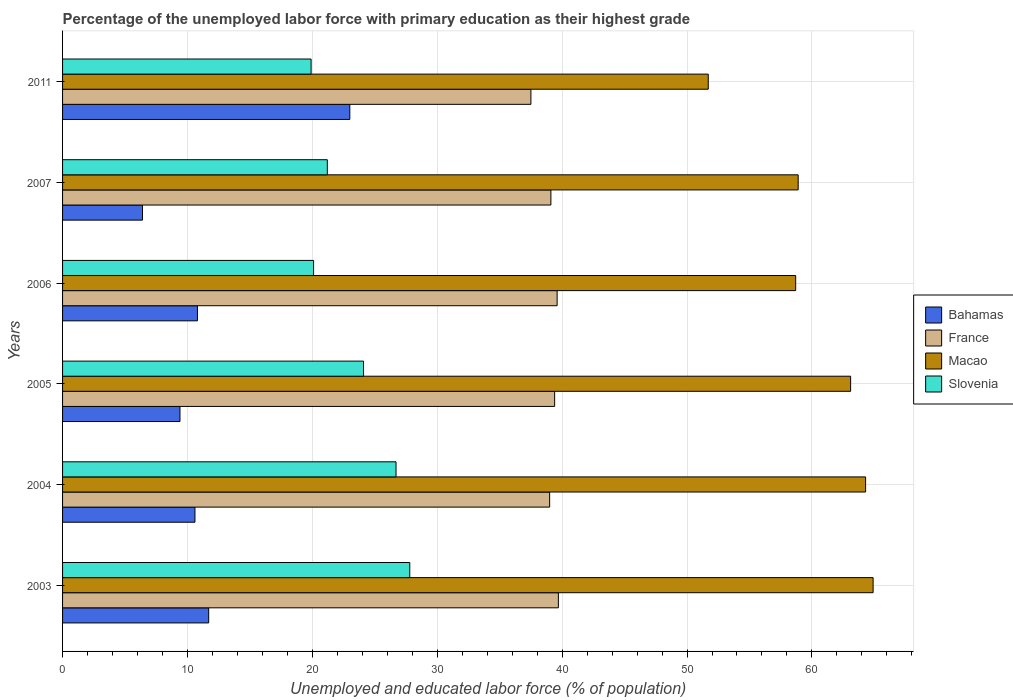How many different coloured bars are there?
Offer a very short reply. 4. What is the label of the 6th group of bars from the top?
Your answer should be compact. 2003. In how many cases, is the number of bars for a given year not equal to the number of legend labels?
Provide a succinct answer. 0. What is the percentage of the unemployed labor force with primary education in Bahamas in 2011?
Give a very brief answer. 23. Across all years, what is the minimum percentage of the unemployed labor force with primary education in Macao?
Your response must be concise. 51.7. What is the total percentage of the unemployed labor force with primary education in Macao in the graph?
Make the answer very short. 361.6. What is the difference between the percentage of the unemployed labor force with primary education in Macao in 2006 and that in 2011?
Keep it short and to the point. 7. What is the difference between the percentage of the unemployed labor force with primary education in France in 2004 and the percentage of the unemployed labor force with primary education in Bahamas in 2006?
Your response must be concise. 28.2. What is the average percentage of the unemployed labor force with primary education in Slovenia per year?
Keep it short and to the point. 23.3. In the year 2005, what is the difference between the percentage of the unemployed labor force with primary education in Macao and percentage of the unemployed labor force with primary education in Bahamas?
Your response must be concise. 53.7. In how many years, is the percentage of the unemployed labor force with primary education in France greater than 6 %?
Offer a terse response. 6. What is the ratio of the percentage of the unemployed labor force with primary education in Slovenia in 2007 to that in 2011?
Your answer should be compact. 1.07. What is the difference between the highest and the second highest percentage of the unemployed labor force with primary education in Slovenia?
Keep it short and to the point. 1.1. What is the difference between the highest and the lowest percentage of the unemployed labor force with primary education in Bahamas?
Provide a succinct answer. 16.6. Is the sum of the percentage of the unemployed labor force with primary education in Macao in 2005 and 2006 greater than the maximum percentage of the unemployed labor force with primary education in Slovenia across all years?
Your response must be concise. Yes. What does the 3rd bar from the top in 2005 represents?
Give a very brief answer. France. What does the 2nd bar from the bottom in 2007 represents?
Provide a succinct answer. France. What is the difference between two consecutive major ticks on the X-axis?
Ensure brevity in your answer.  10. Does the graph contain any zero values?
Provide a succinct answer. No. Does the graph contain grids?
Your response must be concise. Yes. Where does the legend appear in the graph?
Provide a succinct answer. Center right. How are the legend labels stacked?
Ensure brevity in your answer.  Vertical. What is the title of the graph?
Your answer should be very brief. Percentage of the unemployed labor force with primary education as their highest grade. Does "Angola" appear as one of the legend labels in the graph?
Your answer should be very brief. No. What is the label or title of the X-axis?
Your response must be concise. Unemployed and educated labor force (% of population). What is the Unemployed and educated labor force (% of population) of Bahamas in 2003?
Your response must be concise. 11.7. What is the Unemployed and educated labor force (% of population) in France in 2003?
Offer a terse response. 39.7. What is the Unemployed and educated labor force (% of population) of Macao in 2003?
Give a very brief answer. 64.9. What is the Unemployed and educated labor force (% of population) of Slovenia in 2003?
Give a very brief answer. 27.8. What is the Unemployed and educated labor force (% of population) of Bahamas in 2004?
Keep it short and to the point. 10.6. What is the Unemployed and educated labor force (% of population) of France in 2004?
Provide a short and direct response. 39. What is the Unemployed and educated labor force (% of population) in Macao in 2004?
Offer a terse response. 64.3. What is the Unemployed and educated labor force (% of population) in Slovenia in 2004?
Provide a succinct answer. 26.7. What is the Unemployed and educated labor force (% of population) of Bahamas in 2005?
Give a very brief answer. 9.4. What is the Unemployed and educated labor force (% of population) in France in 2005?
Provide a short and direct response. 39.4. What is the Unemployed and educated labor force (% of population) of Macao in 2005?
Offer a terse response. 63.1. What is the Unemployed and educated labor force (% of population) in Slovenia in 2005?
Your answer should be compact. 24.1. What is the Unemployed and educated labor force (% of population) of Bahamas in 2006?
Offer a very short reply. 10.8. What is the Unemployed and educated labor force (% of population) in France in 2006?
Give a very brief answer. 39.6. What is the Unemployed and educated labor force (% of population) in Macao in 2006?
Make the answer very short. 58.7. What is the Unemployed and educated labor force (% of population) in Slovenia in 2006?
Your response must be concise. 20.1. What is the Unemployed and educated labor force (% of population) in Bahamas in 2007?
Ensure brevity in your answer.  6.4. What is the Unemployed and educated labor force (% of population) of France in 2007?
Your response must be concise. 39.1. What is the Unemployed and educated labor force (% of population) in Macao in 2007?
Your answer should be very brief. 58.9. What is the Unemployed and educated labor force (% of population) of Slovenia in 2007?
Your response must be concise. 21.2. What is the Unemployed and educated labor force (% of population) in France in 2011?
Your answer should be compact. 37.5. What is the Unemployed and educated labor force (% of population) of Macao in 2011?
Offer a very short reply. 51.7. What is the Unemployed and educated labor force (% of population) in Slovenia in 2011?
Your answer should be compact. 19.9. Across all years, what is the maximum Unemployed and educated labor force (% of population) of France?
Offer a terse response. 39.7. Across all years, what is the maximum Unemployed and educated labor force (% of population) of Macao?
Your response must be concise. 64.9. Across all years, what is the maximum Unemployed and educated labor force (% of population) in Slovenia?
Your answer should be compact. 27.8. Across all years, what is the minimum Unemployed and educated labor force (% of population) of Bahamas?
Your answer should be very brief. 6.4. Across all years, what is the minimum Unemployed and educated labor force (% of population) in France?
Offer a very short reply. 37.5. Across all years, what is the minimum Unemployed and educated labor force (% of population) in Macao?
Ensure brevity in your answer.  51.7. Across all years, what is the minimum Unemployed and educated labor force (% of population) of Slovenia?
Provide a short and direct response. 19.9. What is the total Unemployed and educated labor force (% of population) in Bahamas in the graph?
Provide a short and direct response. 71.9. What is the total Unemployed and educated labor force (% of population) of France in the graph?
Keep it short and to the point. 234.3. What is the total Unemployed and educated labor force (% of population) in Macao in the graph?
Give a very brief answer. 361.6. What is the total Unemployed and educated labor force (% of population) of Slovenia in the graph?
Give a very brief answer. 139.8. What is the difference between the Unemployed and educated labor force (% of population) in France in 2003 and that in 2004?
Give a very brief answer. 0.7. What is the difference between the Unemployed and educated labor force (% of population) in Macao in 2003 and that in 2004?
Provide a short and direct response. 0.6. What is the difference between the Unemployed and educated labor force (% of population) in Slovenia in 2003 and that in 2004?
Give a very brief answer. 1.1. What is the difference between the Unemployed and educated labor force (% of population) in Bahamas in 2003 and that in 2005?
Keep it short and to the point. 2.3. What is the difference between the Unemployed and educated labor force (% of population) of Slovenia in 2003 and that in 2006?
Your answer should be compact. 7.7. What is the difference between the Unemployed and educated labor force (% of population) of Bahamas in 2003 and that in 2007?
Give a very brief answer. 5.3. What is the difference between the Unemployed and educated labor force (% of population) in Macao in 2003 and that in 2007?
Provide a short and direct response. 6. What is the difference between the Unemployed and educated labor force (% of population) in Macao in 2003 and that in 2011?
Offer a terse response. 13.2. What is the difference between the Unemployed and educated labor force (% of population) in Slovenia in 2003 and that in 2011?
Your answer should be very brief. 7.9. What is the difference between the Unemployed and educated labor force (% of population) in Bahamas in 2004 and that in 2005?
Provide a succinct answer. 1.2. What is the difference between the Unemployed and educated labor force (% of population) of Macao in 2004 and that in 2005?
Make the answer very short. 1.2. What is the difference between the Unemployed and educated labor force (% of population) in Slovenia in 2004 and that in 2005?
Give a very brief answer. 2.6. What is the difference between the Unemployed and educated labor force (% of population) of Slovenia in 2004 and that in 2006?
Your answer should be very brief. 6.6. What is the difference between the Unemployed and educated labor force (% of population) of France in 2004 and that in 2007?
Make the answer very short. -0.1. What is the difference between the Unemployed and educated labor force (% of population) of Macao in 2004 and that in 2007?
Ensure brevity in your answer.  5.4. What is the difference between the Unemployed and educated labor force (% of population) of Slovenia in 2004 and that in 2007?
Keep it short and to the point. 5.5. What is the difference between the Unemployed and educated labor force (% of population) in Macao in 2004 and that in 2011?
Provide a short and direct response. 12.6. What is the difference between the Unemployed and educated labor force (% of population) in Slovenia in 2004 and that in 2011?
Provide a succinct answer. 6.8. What is the difference between the Unemployed and educated labor force (% of population) of France in 2005 and that in 2006?
Offer a very short reply. -0.2. What is the difference between the Unemployed and educated labor force (% of population) of Macao in 2005 and that in 2006?
Offer a terse response. 4.4. What is the difference between the Unemployed and educated labor force (% of population) of France in 2005 and that in 2007?
Offer a very short reply. 0.3. What is the difference between the Unemployed and educated labor force (% of population) in Macao in 2005 and that in 2007?
Keep it short and to the point. 4.2. What is the difference between the Unemployed and educated labor force (% of population) of Slovenia in 2005 and that in 2007?
Your answer should be compact. 2.9. What is the difference between the Unemployed and educated labor force (% of population) of Bahamas in 2005 and that in 2011?
Provide a succinct answer. -13.6. What is the difference between the Unemployed and educated labor force (% of population) of Macao in 2005 and that in 2011?
Your answer should be very brief. 11.4. What is the difference between the Unemployed and educated labor force (% of population) in Slovenia in 2005 and that in 2011?
Ensure brevity in your answer.  4.2. What is the difference between the Unemployed and educated labor force (% of population) in France in 2006 and that in 2007?
Keep it short and to the point. 0.5. What is the difference between the Unemployed and educated labor force (% of population) in Macao in 2006 and that in 2007?
Your response must be concise. -0.2. What is the difference between the Unemployed and educated labor force (% of population) in Slovenia in 2006 and that in 2007?
Provide a succinct answer. -1.1. What is the difference between the Unemployed and educated labor force (% of population) of Bahamas in 2006 and that in 2011?
Provide a succinct answer. -12.2. What is the difference between the Unemployed and educated labor force (% of population) of Slovenia in 2006 and that in 2011?
Make the answer very short. 0.2. What is the difference between the Unemployed and educated labor force (% of population) of Bahamas in 2007 and that in 2011?
Give a very brief answer. -16.6. What is the difference between the Unemployed and educated labor force (% of population) in France in 2007 and that in 2011?
Make the answer very short. 1.6. What is the difference between the Unemployed and educated labor force (% of population) in Bahamas in 2003 and the Unemployed and educated labor force (% of population) in France in 2004?
Offer a terse response. -27.3. What is the difference between the Unemployed and educated labor force (% of population) of Bahamas in 2003 and the Unemployed and educated labor force (% of population) of Macao in 2004?
Keep it short and to the point. -52.6. What is the difference between the Unemployed and educated labor force (% of population) in Bahamas in 2003 and the Unemployed and educated labor force (% of population) in Slovenia in 2004?
Ensure brevity in your answer.  -15. What is the difference between the Unemployed and educated labor force (% of population) of France in 2003 and the Unemployed and educated labor force (% of population) of Macao in 2004?
Your answer should be compact. -24.6. What is the difference between the Unemployed and educated labor force (% of population) in France in 2003 and the Unemployed and educated labor force (% of population) in Slovenia in 2004?
Provide a short and direct response. 13. What is the difference between the Unemployed and educated labor force (% of population) in Macao in 2003 and the Unemployed and educated labor force (% of population) in Slovenia in 2004?
Provide a short and direct response. 38.2. What is the difference between the Unemployed and educated labor force (% of population) in Bahamas in 2003 and the Unemployed and educated labor force (% of population) in France in 2005?
Keep it short and to the point. -27.7. What is the difference between the Unemployed and educated labor force (% of population) of Bahamas in 2003 and the Unemployed and educated labor force (% of population) of Macao in 2005?
Provide a succinct answer. -51.4. What is the difference between the Unemployed and educated labor force (% of population) in Bahamas in 2003 and the Unemployed and educated labor force (% of population) in Slovenia in 2005?
Provide a succinct answer. -12.4. What is the difference between the Unemployed and educated labor force (% of population) in France in 2003 and the Unemployed and educated labor force (% of population) in Macao in 2005?
Give a very brief answer. -23.4. What is the difference between the Unemployed and educated labor force (% of population) in France in 2003 and the Unemployed and educated labor force (% of population) in Slovenia in 2005?
Your answer should be very brief. 15.6. What is the difference between the Unemployed and educated labor force (% of population) of Macao in 2003 and the Unemployed and educated labor force (% of population) of Slovenia in 2005?
Offer a very short reply. 40.8. What is the difference between the Unemployed and educated labor force (% of population) of Bahamas in 2003 and the Unemployed and educated labor force (% of population) of France in 2006?
Offer a terse response. -27.9. What is the difference between the Unemployed and educated labor force (% of population) in Bahamas in 2003 and the Unemployed and educated labor force (% of population) in Macao in 2006?
Provide a succinct answer. -47. What is the difference between the Unemployed and educated labor force (% of population) of Bahamas in 2003 and the Unemployed and educated labor force (% of population) of Slovenia in 2006?
Your answer should be compact. -8.4. What is the difference between the Unemployed and educated labor force (% of population) of France in 2003 and the Unemployed and educated labor force (% of population) of Slovenia in 2006?
Make the answer very short. 19.6. What is the difference between the Unemployed and educated labor force (% of population) in Macao in 2003 and the Unemployed and educated labor force (% of population) in Slovenia in 2006?
Ensure brevity in your answer.  44.8. What is the difference between the Unemployed and educated labor force (% of population) in Bahamas in 2003 and the Unemployed and educated labor force (% of population) in France in 2007?
Offer a very short reply. -27.4. What is the difference between the Unemployed and educated labor force (% of population) of Bahamas in 2003 and the Unemployed and educated labor force (% of population) of Macao in 2007?
Ensure brevity in your answer.  -47.2. What is the difference between the Unemployed and educated labor force (% of population) of France in 2003 and the Unemployed and educated labor force (% of population) of Macao in 2007?
Your answer should be compact. -19.2. What is the difference between the Unemployed and educated labor force (% of population) of France in 2003 and the Unemployed and educated labor force (% of population) of Slovenia in 2007?
Ensure brevity in your answer.  18.5. What is the difference between the Unemployed and educated labor force (% of population) of Macao in 2003 and the Unemployed and educated labor force (% of population) of Slovenia in 2007?
Keep it short and to the point. 43.7. What is the difference between the Unemployed and educated labor force (% of population) in Bahamas in 2003 and the Unemployed and educated labor force (% of population) in France in 2011?
Provide a short and direct response. -25.8. What is the difference between the Unemployed and educated labor force (% of population) in Bahamas in 2003 and the Unemployed and educated labor force (% of population) in Macao in 2011?
Keep it short and to the point. -40. What is the difference between the Unemployed and educated labor force (% of population) in France in 2003 and the Unemployed and educated labor force (% of population) in Slovenia in 2011?
Your answer should be compact. 19.8. What is the difference between the Unemployed and educated labor force (% of population) in Macao in 2003 and the Unemployed and educated labor force (% of population) in Slovenia in 2011?
Provide a short and direct response. 45. What is the difference between the Unemployed and educated labor force (% of population) of Bahamas in 2004 and the Unemployed and educated labor force (% of population) of France in 2005?
Provide a succinct answer. -28.8. What is the difference between the Unemployed and educated labor force (% of population) of Bahamas in 2004 and the Unemployed and educated labor force (% of population) of Macao in 2005?
Your response must be concise. -52.5. What is the difference between the Unemployed and educated labor force (% of population) in Bahamas in 2004 and the Unemployed and educated labor force (% of population) in Slovenia in 2005?
Offer a very short reply. -13.5. What is the difference between the Unemployed and educated labor force (% of population) in France in 2004 and the Unemployed and educated labor force (% of population) in Macao in 2005?
Provide a short and direct response. -24.1. What is the difference between the Unemployed and educated labor force (% of population) of France in 2004 and the Unemployed and educated labor force (% of population) of Slovenia in 2005?
Your response must be concise. 14.9. What is the difference between the Unemployed and educated labor force (% of population) of Macao in 2004 and the Unemployed and educated labor force (% of population) of Slovenia in 2005?
Give a very brief answer. 40.2. What is the difference between the Unemployed and educated labor force (% of population) in Bahamas in 2004 and the Unemployed and educated labor force (% of population) in France in 2006?
Provide a short and direct response. -29. What is the difference between the Unemployed and educated labor force (% of population) of Bahamas in 2004 and the Unemployed and educated labor force (% of population) of Macao in 2006?
Offer a very short reply. -48.1. What is the difference between the Unemployed and educated labor force (% of population) of France in 2004 and the Unemployed and educated labor force (% of population) of Macao in 2006?
Provide a succinct answer. -19.7. What is the difference between the Unemployed and educated labor force (% of population) of Macao in 2004 and the Unemployed and educated labor force (% of population) of Slovenia in 2006?
Offer a terse response. 44.2. What is the difference between the Unemployed and educated labor force (% of population) of Bahamas in 2004 and the Unemployed and educated labor force (% of population) of France in 2007?
Provide a succinct answer. -28.5. What is the difference between the Unemployed and educated labor force (% of population) in Bahamas in 2004 and the Unemployed and educated labor force (% of population) in Macao in 2007?
Provide a succinct answer. -48.3. What is the difference between the Unemployed and educated labor force (% of population) of France in 2004 and the Unemployed and educated labor force (% of population) of Macao in 2007?
Give a very brief answer. -19.9. What is the difference between the Unemployed and educated labor force (% of population) in Macao in 2004 and the Unemployed and educated labor force (% of population) in Slovenia in 2007?
Give a very brief answer. 43.1. What is the difference between the Unemployed and educated labor force (% of population) in Bahamas in 2004 and the Unemployed and educated labor force (% of population) in France in 2011?
Your answer should be very brief. -26.9. What is the difference between the Unemployed and educated labor force (% of population) of Bahamas in 2004 and the Unemployed and educated labor force (% of population) of Macao in 2011?
Make the answer very short. -41.1. What is the difference between the Unemployed and educated labor force (% of population) in Bahamas in 2004 and the Unemployed and educated labor force (% of population) in Slovenia in 2011?
Offer a terse response. -9.3. What is the difference between the Unemployed and educated labor force (% of population) in France in 2004 and the Unemployed and educated labor force (% of population) in Slovenia in 2011?
Your answer should be compact. 19.1. What is the difference between the Unemployed and educated labor force (% of population) in Macao in 2004 and the Unemployed and educated labor force (% of population) in Slovenia in 2011?
Provide a succinct answer. 44.4. What is the difference between the Unemployed and educated labor force (% of population) of Bahamas in 2005 and the Unemployed and educated labor force (% of population) of France in 2006?
Offer a very short reply. -30.2. What is the difference between the Unemployed and educated labor force (% of population) in Bahamas in 2005 and the Unemployed and educated labor force (% of population) in Macao in 2006?
Provide a short and direct response. -49.3. What is the difference between the Unemployed and educated labor force (% of population) of France in 2005 and the Unemployed and educated labor force (% of population) of Macao in 2006?
Provide a succinct answer. -19.3. What is the difference between the Unemployed and educated labor force (% of population) in France in 2005 and the Unemployed and educated labor force (% of population) in Slovenia in 2006?
Make the answer very short. 19.3. What is the difference between the Unemployed and educated labor force (% of population) of Bahamas in 2005 and the Unemployed and educated labor force (% of population) of France in 2007?
Offer a very short reply. -29.7. What is the difference between the Unemployed and educated labor force (% of population) of Bahamas in 2005 and the Unemployed and educated labor force (% of population) of Macao in 2007?
Provide a short and direct response. -49.5. What is the difference between the Unemployed and educated labor force (% of population) in France in 2005 and the Unemployed and educated labor force (% of population) in Macao in 2007?
Offer a terse response. -19.5. What is the difference between the Unemployed and educated labor force (% of population) of Macao in 2005 and the Unemployed and educated labor force (% of population) of Slovenia in 2007?
Your response must be concise. 41.9. What is the difference between the Unemployed and educated labor force (% of population) of Bahamas in 2005 and the Unemployed and educated labor force (% of population) of France in 2011?
Your response must be concise. -28.1. What is the difference between the Unemployed and educated labor force (% of population) of Bahamas in 2005 and the Unemployed and educated labor force (% of population) of Macao in 2011?
Offer a terse response. -42.3. What is the difference between the Unemployed and educated labor force (% of population) of Bahamas in 2005 and the Unemployed and educated labor force (% of population) of Slovenia in 2011?
Provide a short and direct response. -10.5. What is the difference between the Unemployed and educated labor force (% of population) in France in 2005 and the Unemployed and educated labor force (% of population) in Macao in 2011?
Offer a very short reply. -12.3. What is the difference between the Unemployed and educated labor force (% of population) in Macao in 2005 and the Unemployed and educated labor force (% of population) in Slovenia in 2011?
Your response must be concise. 43.2. What is the difference between the Unemployed and educated labor force (% of population) in Bahamas in 2006 and the Unemployed and educated labor force (% of population) in France in 2007?
Your response must be concise. -28.3. What is the difference between the Unemployed and educated labor force (% of population) of Bahamas in 2006 and the Unemployed and educated labor force (% of population) of Macao in 2007?
Provide a short and direct response. -48.1. What is the difference between the Unemployed and educated labor force (% of population) of Bahamas in 2006 and the Unemployed and educated labor force (% of population) of Slovenia in 2007?
Ensure brevity in your answer.  -10.4. What is the difference between the Unemployed and educated labor force (% of population) of France in 2006 and the Unemployed and educated labor force (% of population) of Macao in 2007?
Ensure brevity in your answer.  -19.3. What is the difference between the Unemployed and educated labor force (% of population) of France in 2006 and the Unemployed and educated labor force (% of population) of Slovenia in 2007?
Offer a terse response. 18.4. What is the difference between the Unemployed and educated labor force (% of population) of Macao in 2006 and the Unemployed and educated labor force (% of population) of Slovenia in 2007?
Ensure brevity in your answer.  37.5. What is the difference between the Unemployed and educated labor force (% of population) in Bahamas in 2006 and the Unemployed and educated labor force (% of population) in France in 2011?
Your answer should be very brief. -26.7. What is the difference between the Unemployed and educated labor force (% of population) in Bahamas in 2006 and the Unemployed and educated labor force (% of population) in Macao in 2011?
Keep it short and to the point. -40.9. What is the difference between the Unemployed and educated labor force (% of population) of Bahamas in 2006 and the Unemployed and educated labor force (% of population) of Slovenia in 2011?
Your answer should be very brief. -9.1. What is the difference between the Unemployed and educated labor force (% of population) of France in 2006 and the Unemployed and educated labor force (% of population) of Slovenia in 2011?
Keep it short and to the point. 19.7. What is the difference between the Unemployed and educated labor force (% of population) of Macao in 2006 and the Unemployed and educated labor force (% of population) of Slovenia in 2011?
Ensure brevity in your answer.  38.8. What is the difference between the Unemployed and educated labor force (% of population) in Bahamas in 2007 and the Unemployed and educated labor force (% of population) in France in 2011?
Your answer should be compact. -31.1. What is the difference between the Unemployed and educated labor force (% of population) of Bahamas in 2007 and the Unemployed and educated labor force (% of population) of Macao in 2011?
Offer a terse response. -45.3. What is the difference between the Unemployed and educated labor force (% of population) of Bahamas in 2007 and the Unemployed and educated labor force (% of population) of Slovenia in 2011?
Offer a terse response. -13.5. What is the difference between the Unemployed and educated labor force (% of population) in Macao in 2007 and the Unemployed and educated labor force (% of population) in Slovenia in 2011?
Provide a succinct answer. 39. What is the average Unemployed and educated labor force (% of population) of Bahamas per year?
Offer a terse response. 11.98. What is the average Unemployed and educated labor force (% of population) of France per year?
Provide a succinct answer. 39.05. What is the average Unemployed and educated labor force (% of population) in Macao per year?
Ensure brevity in your answer.  60.27. What is the average Unemployed and educated labor force (% of population) of Slovenia per year?
Your answer should be compact. 23.3. In the year 2003, what is the difference between the Unemployed and educated labor force (% of population) in Bahamas and Unemployed and educated labor force (% of population) in France?
Ensure brevity in your answer.  -28. In the year 2003, what is the difference between the Unemployed and educated labor force (% of population) of Bahamas and Unemployed and educated labor force (% of population) of Macao?
Your response must be concise. -53.2. In the year 2003, what is the difference between the Unemployed and educated labor force (% of population) in Bahamas and Unemployed and educated labor force (% of population) in Slovenia?
Make the answer very short. -16.1. In the year 2003, what is the difference between the Unemployed and educated labor force (% of population) of France and Unemployed and educated labor force (% of population) of Macao?
Give a very brief answer. -25.2. In the year 2003, what is the difference between the Unemployed and educated labor force (% of population) in France and Unemployed and educated labor force (% of population) in Slovenia?
Ensure brevity in your answer.  11.9. In the year 2003, what is the difference between the Unemployed and educated labor force (% of population) in Macao and Unemployed and educated labor force (% of population) in Slovenia?
Your answer should be compact. 37.1. In the year 2004, what is the difference between the Unemployed and educated labor force (% of population) in Bahamas and Unemployed and educated labor force (% of population) in France?
Make the answer very short. -28.4. In the year 2004, what is the difference between the Unemployed and educated labor force (% of population) in Bahamas and Unemployed and educated labor force (% of population) in Macao?
Your response must be concise. -53.7. In the year 2004, what is the difference between the Unemployed and educated labor force (% of population) in Bahamas and Unemployed and educated labor force (% of population) in Slovenia?
Offer a terse response. -16.1. In the year 2004, what is the difference between the Unemployed and educated labor force (% of population) in France and Unemployed and educated labor force (% of population) in Macao?
Ensure brevity in your answer.  -25.3. In the year 2004, what is the difference between the Unemployed and educated labor force (% of population) in France and Unemployed and educated labor force (% of population) in Slovenia?
Offer a terse response. 12.3. In the year 2004, what is the difference between the Unemployed and educated labor force (% of population) of Macao and Unemployed and educated labor force (% of population) of Slovenia?
Your answer should be very brief. 37.6. In the year 2005, what is the difference between the Unemployed and educated labor force (% of population) of Bahamas and Unemployed and educated labor force (% of population) of France?
Offer a very short reply. -30. In the year 2005, what is the difference between the Unemployed and educated labor force (% of population) of Bahamas and Unemployed and educated labor force (% of population) of Macao?
Offer a very short reply. -53.7. In the year 2005, what is the difference between the Unemployed and educated labor force (% of population) of Bahamas and Unemployed and educated labor force (% of population) of Slovenia?
Provide a succinct answer. -14.7. In the year 2005, what is the difference between the Unemployed and educated labor force (% of population) of France and Unemployed and educated labor force (% of population) of Macao?
Keep it short and to the point. -23.7. In the year 2005, what is the difference between the Unemployed and educated labor force (% of population) of France and Unemployed and educated labor force (% of population) of Slovenia?
Give a very brief answer. 15.3. In the year 2006, what is the difference between the Unemployed and educated labor force (% of population) in Bahamas and Unemployed and educated labor force (% of population) in France?
Provide a short and direct response. -28.8. In the year 2006, what is the difference between the Unemployed and educated labor force (% of population) in Bahamas and Unemployed and educated labor force (% of population) in Macao?
Offer a very short reply. -47.9. In the year 2006, what is the difference between the Unemployed and educated labor force (% of population) of France and Unemployed and educated labor force (% of population) of Macao?
Offer a terse response. -19.1. In the year 2006, what is the difference between the Unemployed and educated labor force (% of population) of France and Unemployed and educated labor force (% of population) of Slovenia?
Your answer should be very brief. 19.5. In the year 2006, what is the difference between the Unemployed and educated labor force (% of population) in Macao and Unemployed and educated labor force (% of population) in Slovenia?
Provide a short and direct response. 38.6. In the year 2007, what is the difference between the Unemployed and educated labor force (% of population) in Bahamas and Unemployed and educated labor force (% of population) in France?
Offer a terse response. -32.7. In the year 2007, what is the difference between the Unemployed and educated labor force (% of population) of Bahamas and Unemployed and educated labor force (% of population) of Macao?
Offer a very short reply. -52.5. In the year 2007, what is the difference between the Unemployed and educated labor force (% of population) of Bahamas and Unemployed and educated labor force (% of population) of Slovenia?
Provide a short and direct response. -14.8. In the year 2007, what is the difference between the Unemployed and educated labor force (% of population) of France and Unemployed and educated labor force (% of population) of Macao?
Your answer should be compact. -19.8. In the year 2007, what is the difference between the Unemployed and educated labor force (% of population) in France and Unemployed and educated labor force (% of population) in Slovenia?
Provide a succinct answer. 17.9. In the year 2007, what is the difference between the Unemployed and educated labor force (% of population) of Macao and Unemployed and educated labor force (% of population) of Slovenia?
Your answer should be compact. 37.7. In the year 2011, what is the difference between the Unemployed and educated labor force (% of population) of Bahamas and Unemployed and educated labor force (% of population) of France?
Make the answer very short. -14.5. In the year 2011, what is the difference between the Unemployed and educated labor force (% of population) of Bahamas and Unemployed and educated labor force (% of population) of Macao?
Offer a terse response. -28.7. In the year 2011, what is the difference between the Unemployed and educated labor force (% of population) in Macao and Unemployed and educated labor force (% of population) in Slovenia?
Provide a short and direct response. 31.8. What is the ratio of the Unemployed and educated labor force (% of population) of Bahamas in 2003 to that in 2004?
Provide a short and direct response. 1.1. What is the ratio of the Unemployed and educated labor force (% of population) of France in 2003 to that in 2004?
Provide a succinct answer. 1.02. What is the ratio of the Unemployed and educated labor force (% of population) in Macao in 2003 to that in 2004?
Provide a succinct answer. 1.01. What is the ratio of the Unemployed and educated labor force (% of population) in Slovenia in 2003 to that in 2004?
Give a very brief answer. 1.04. What is the ratio of the Unemployed and educated labor force (% of population) of Bahamas in 2003 to that in 2005?
Make the answer very short. 1.24. What is the ratio of the Unemployed and educated labor force (% of population) in France in 2003 to that in 2005?
Offer a very short reply. 1.01. What is the ratio of the Unemployed and educated labor force (% of population) of Macao in 2003 to that in 2005?
Offer a terse response. 1.03. What is the ratio of the Unemployed and educated labor force (% of population) of Slovenia in 2003 to that in 2005?
Offer a very short reply. 1.15. What is the ratio of the Unemployed and educated labor force (% of population) of Bahamas in 2003 to that in 2006?
Your response must be concise. 1.08. What is the ratio of the Unemployed and educated labor force (% of population) in Macao in 2003 to that in 2006?
Provide a short and direct response. 1.11. What is the ratio of the Unemployed and educated labor force (% of population) in Slovenia in 2003 to that in 2006?
Give a very brief answer. 1.38. What is the ratio of the Unemployed and educated labor force (% of population) in Bahamas in 2003 to that in 2007?
Your answer should be compact. 1.83. What is the ratio of the Unemployed and educated labor force (% of population) of France in 2003 to that in 2007?
Your answer should be compact. 1.02. What is the ratio of the Unemployed and educated labor force (% of population) of Macao in 2003 to that in 2007?
Provide a succinct answer. 1.1. What is the ratio of the Unemployed and educated labor force (% of population) in Slovenia in 2003 to that in 2007?
Provide a short and direct response. 1.31. What is the ratio of the Unemployed and educated labor force (% of population) of Bahamas in 2003 to that in 2011?
Offer a terse response. 0.51. What is the ratio of the Unemployed and educated labor force (% of population) in France in 2003 to that in 2011?
Offer a terse response. 1.06. What is the ratio of the Unemployed and educated labor force (% of population) of Macao in 2003 to that in 2011?
Provide a succinct answer. 1.26. What is the ratio of the Unemployed and educated labor force (% of population) in Slovenia in 2003 to that in 2011?
Your response must be concise. 1.4. What is the ratio of the Unemployed and educated labor force (% of population) of Bahamas in 2004 to that in 2005?
Your answer should be very brief. 1.13. What is the ratio of the Unemployed and educated labor force (% of population) of Macao in 2004 to that in 2005?
Offer a terse response. 1.02. What is the ratio of the Unemployed and educated labor force (% of population) of Slovenia in 2004 to that in 2005?
Your response must be concise. 1.11. What is the ratio of the Unemployed and educated labor force (% of population) of Bahamas in 2004 to that in 2006?
Give a very brief answer. 0.98. What is the ratio of the Unemployed and educated labor force (% of population) in Macao in 2004 to that in 2006?
Ensure brevity in your answer.  1.1. What is the ratio of the Unemployed and educated labor force (% of population) of Slovenia in 2004 to that in 2006?
Provide a short and direct response. 1.33. What is the ratio of the Unemployed and educated labor force (% of population) of Bahamas in 2004 to that in 2007?
Make the answer very short. 1.66. What is the ratio of the Unemployed and educated labor force (% of population) of France in 2004 to that in 2007?
Ensure brevity in your answer.  1. What is the ratio of the Unemployed and educated labor force (% of population) in Macao in 2004 to that in 2007?
Your response must be concise. 1.09. What is the ratio of the Unemployed and educated labor force (% of population) of Slovenia in 2004 to that in 2007?
Provide a succinct answer. 1.26. What is the ratio of the Unemployed and educated labor force (% of population) in Bahamas in 2004 to that in 2011?
Keep it short and to the point. 0.46. What is the ratio of the Unemployed and educated labor force (% of population) in France in 2004 to that in 2011?
Provide a short and direct response. 1.04. What is the ratio of the Unemployed and educated labor force (% of population) in Macao in 2004 to that in 2011?
Offer a very short reply. 1.24. What is the ratio of the Unemployed and educated labor force (% of population) of Slovenia in 2004 to that in 2011?
Offer a terse response. 1.34. What is the ratio of the Unemployed and educated labor force (% of population) in Bahamas in 2005 to that in 2006?
Your response must be concise. 0.87. What is the ratio of the Unemployed and educated labor force (% of population) of Macao in 2005 to that in 2006?
Your answer should be very brief. 1.07. What is the ratio of the Unemployed and educated labor force (% of population) of Slovenia in 2005 to that in 2006?
Your answer should be compact. 1.2. What is the ratio of the Unemployed and educated labor force (% of population) of Bahamas in 2005 to that in 2007?
Your response must be concise. 1.47. What is the ratio of the Unemployed and educated labor force (% of population) of France in 2005 to that in 2007?
Ensure brevity in your answer.  1.01. What is the ratio of the Unemployed and educated labor force (% of population) of Macao in 2005 to that in 2007?
Provide a short and direct response. 1.07. What is the ratio of the Unemployed and educated labor force (% of population) of Slovenia in 2005 to that in 2007?
Ensure brevity in your answer.  1.14. What is the ratio of the Unemployed and educated labor force (% of population) in Bahamas in 2005 to that in 2011?
Offer a terse response. 0.41. What is the ratio of the Unemployed and educated labor force (% of population) in France in 2005 to that in 2011?
Your answer should be compact. 1.05. What is the ratio of the Unemployed and educated labor force (% of population) in Macao in 2005 to that in 2011?
Give a very brief answer. 1.22. What is the ratio of the Unemployed and educated labor force (% of population) in Slovenia in 2005 to that in 2011?
Your answer should be very brief. 1.21. What is the ratio of the Unemployed and educated labor force (% of population) of Bahamas in 2006 to that in 2007?
Your answer should be compact. 1.69. What is the ratio of the Unemployed and educated labor force (% of population) of France in 2006 to that in 2007?
Your answer should be very brief. 1.01. What is the ratio of the Unemployed and educated labor force (% of population) in Macao in 2006 to that in 2007?
Offer a very short reply. 1. What is the ratio of the Unemployed and educated labor force (% of population) in Slovenia in 2006 to that in 2007?
Provide a short and direct response. 0.95. What is the ratio of the Unemployed and educated labor force (% of population) in Bahamas in 2006 to that in 2011?
Provide a short and direct response. 0.47. What is the ratio of the Unemployed and educated labor force (% of population) in France in 2006 to that in 2011?
Provide a succinct answer. 1.06. What is the ratio of the Unemployed and educated labor force (% of population) in Macao in 2006 to that in 2011?
Give a very brief answer. 1.14. What is the ratio of the Unemployed and educated labor force (% of population) in Slovenia in 2006 to that in 2011?
Provide a succinct answer. 1.01. What is the ratio of the Unemployed and educated labor force (% of population) of Bahamas in 2007 to that in 2011?
Provide a succinct answer. 0.28. What is the ratio of the Unemployed and educated labor force (% of population) of France in 2007 to that in 2011?
Your answer should be compact. 1.04. What is the ratio of the Unemployed and educated labor force (% of population) of Macao in 2007 to that in 2011?
Ensure brevity in your answer.  1.14. What is the ratio of the Unemployed and educated labor force (% of population) in Slovenia in 2007 to that in 2011?
Give a very brief answer. 1.07. What is the difference between the highest and the second highest Unemployed and educated labor force (% of population) of Bahamas?
Give a very brief answer. 11.3. What is the difference between the highest and the second highest Unemployed and educated labor force (% of population) of France?
Offer a very short reply. 0.1. What is the difference between the highest and the second highest Unemployed and educated labor force (% of population) of Macao?
Offer a terse response. 0.6. What is the difference between the highest and the lowest Unemployed and educated labor force (% of population) in Macao?
Give a very brief answer. 13.2. 